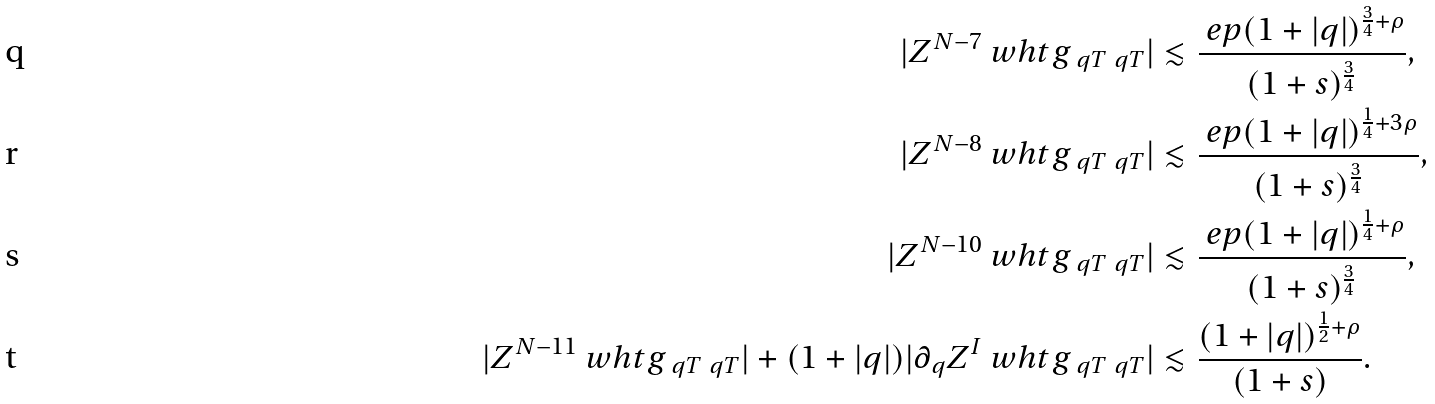<formula> <loc_0><loc_0><loc_500><loc_500>| Z ^ { N - 7 } \ w h t g _ { \ q T \ q T } | & \lesssim \frac { \ e p ( 1 + | q | ) ^ { \frac { 3 } { 4 } + \rho } } { ( 1 + s ) ^ { \frac { 3 } { 4 } } } , \\ | Z ^ { N - 8 } \ w h t g _ { \ q T \ q T } | & \lesssim \frac { \ e p ( 1 + | q | ) ^ { \frac { 1 } { 4 } + 3 \rho } } { ( 1 + s ) ^ { \frac { 3 } { 4 } } } , \\ | Z ^ { N - 1 0 } \ w h t g _ { \ q T \ q T } | & \lesssim \frac { \ e p ( 1 + | q | ) ^ { \frac { 1 } { 4 } + \rho } } { ( 1 + s ) ^ { \frac { 3 } { 4 } } } , \\ | Z ^ { N - 1 1 } \ w h t g _ { \ q T \ q T } | + ( 1 + | q | ) | \partial _ { q } Z ^ { I } \ w h t g _ { \ q T \ q T } | & \lesssim \frac { ( 1 + | q | ) ^ { \frac { 1 } { 2 } + \rho } } { ( 1 + s ) } .</formula> 